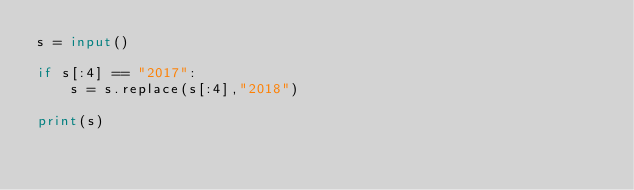Convert code to text. <code><loc_0><loc_0><loc_500><loc_500><_Python_>s = input()

if s[:4] == "2017":
    s = s.replace(s[:4],"2018")
    
print(s)</code> 